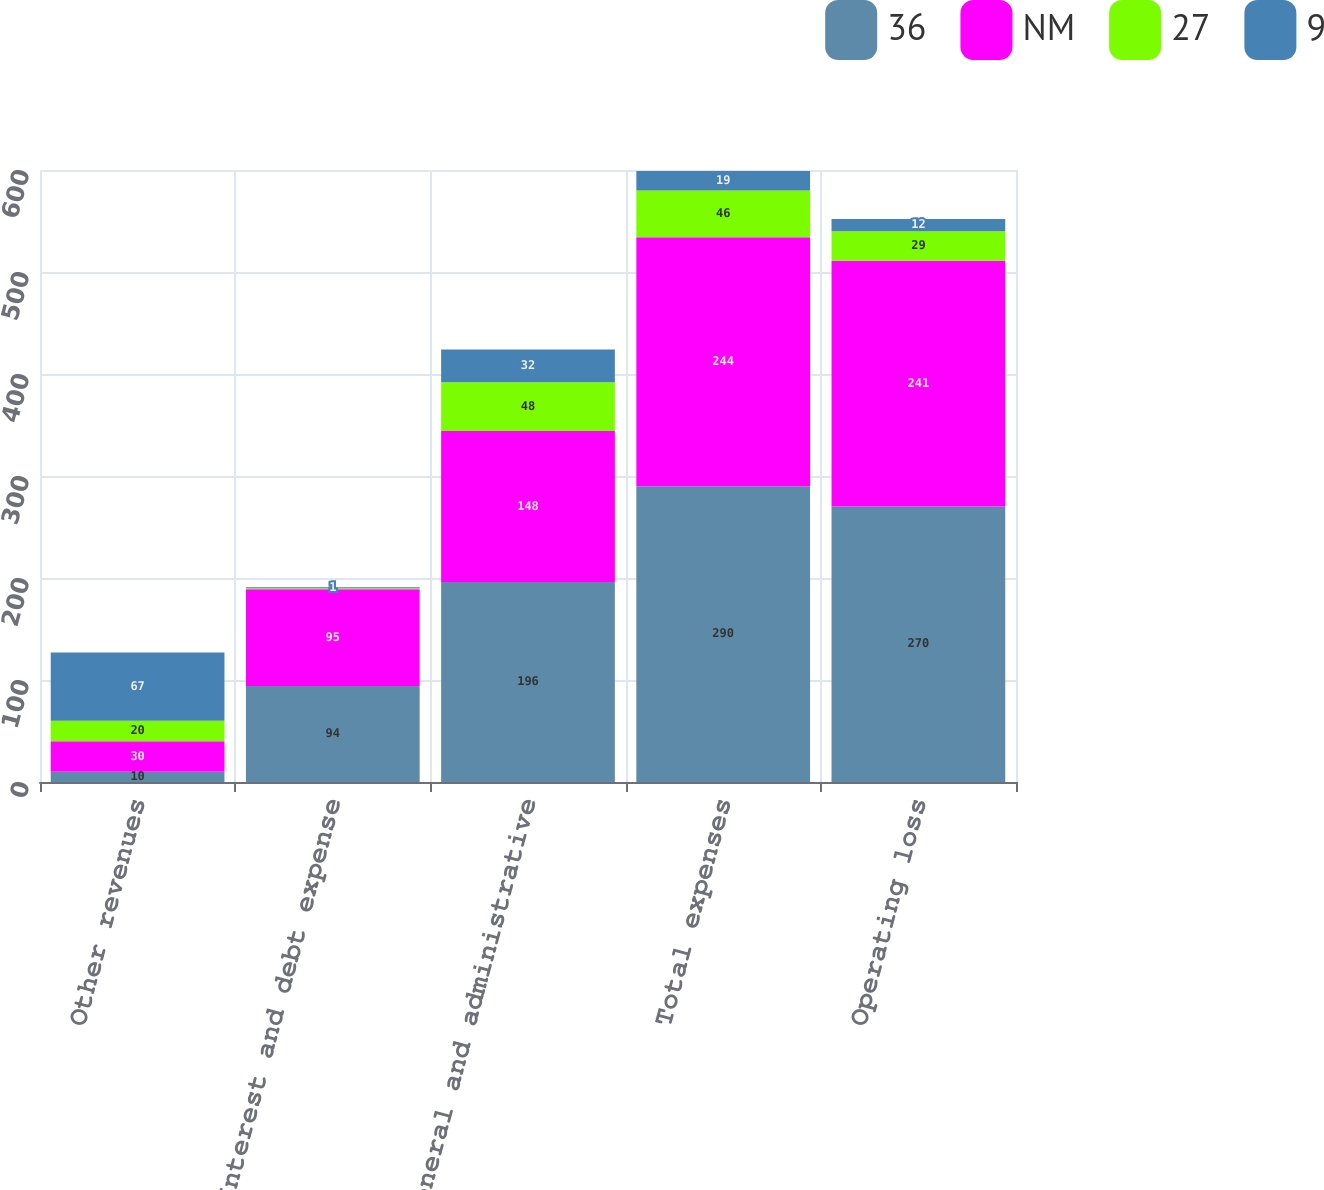Convert chart to OTSL. <chart><loc_0><loc_0><loc_500><loc_500><stacked_bar_chart><ecel><fcel>Other revenues<fcel>Interest and debt expense<fcel>General and administrative<fcel>Total expenses<fcel>Operating loss<nl><fcel>36<fcel>10<fcel>94<fcel>196<fcel>290<fcel>270<nl><fcel>NM<fcel>30<fcel>95<fcel>148<fcel>244<fcel>241<nl><fcel>27<fcel>20<fcel>1<fcel>48<fcel>46<fcel>29<nl><fcel>9<fcel>67<fcel>1<fcel>32<fcel>19<fcel>12<nl></chart> 